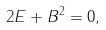<formula> <loc_0><loc_0><loc_500><loc_500>2 E + B ^ { 2 } = 0 ,</formula> 